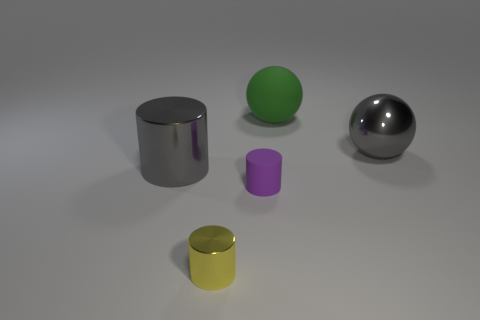What size is the thing that is the same color as the metallic ball?
Your response must be concise. Large. What number of things are either big things to the left of the gray shiny sphere or large red metal blocks?
Offer a terse response. 2. Are there the same number of shiny balls in front of the tiny purple object and big rubber cylinders?
Offer a terse response. Yes. Is the gray metal sphere the same size as the gray shiny cylinder?
Provide a short and direct response. Yes. There is another cylinder that is the same size as the yellow shiny cylinder; what color is it?
Offer a terse response. Purple. Do the gray metallic sphere and the purple cylinder in front of the big metal cylinder have the same size?
Provide a succinct answer. No. How many large spheres have the same color as the large metallic cylinder?
Offer a very short reply. 1. What number of objects are yellow objects or things that are left of the gray ball?
Ensure brevity in your answer.  4. Does the metal thing that is behind the big gray cylinder have the same size as the cylinder to the left of the yellow object?
Ensure brevity in your answer.  Yes. Is there a purple thing made of the same material as the large gray cylinder?
Offer a terse response. No. 